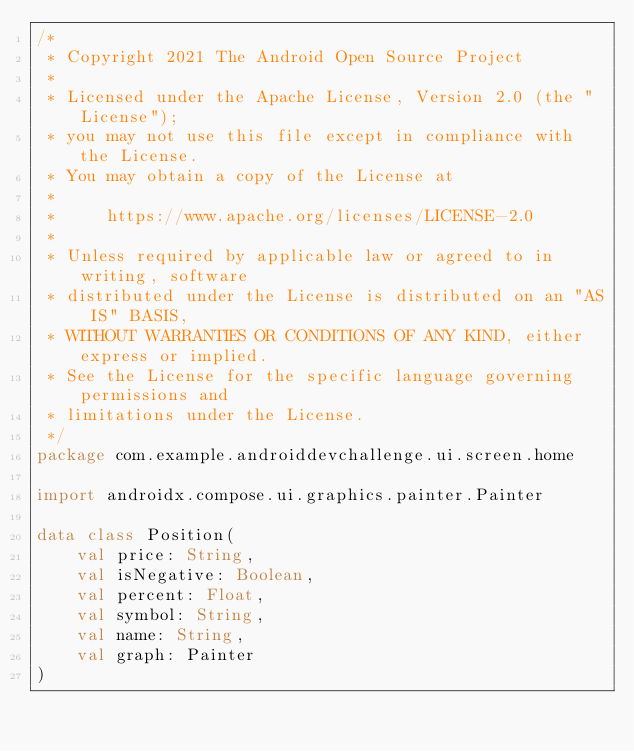Convert code to text. <code><loc_0><loc_0><loc_500><loc_500><_Kotlin_>/*
 * Copyright 2021 The Android Open Source Project
 *
 * Licensed under the Apache License, Version 2.0 (the "License");
 * you may not use this file except in compliance with the License.
 * You may obtain a copy of the License at
 *
 *     https://www.apache.org/licenses/LICENSE-2.0
 *
 * Unless required by applicable law or agreed to in writing, software
 * distributed under the License is distributed on an "AS IS" BASIS,
 * WITHOUT WARRANTIES OR CONDITIONS OF ANY KIND, either express or implied.
 * See the License for the specific language governing permissions and
 * limitations under the License.
 */
package com.example.androiddevchallenge.ui.screen.home

import androidx.compose.ui.graphics.painter.Painter

data class Position(
    val price: String,
    val isNegative: Boolean,
    val percent: Float,
    val symbol: String,
    val name: String,
    val graph: Painter
)
</code> 